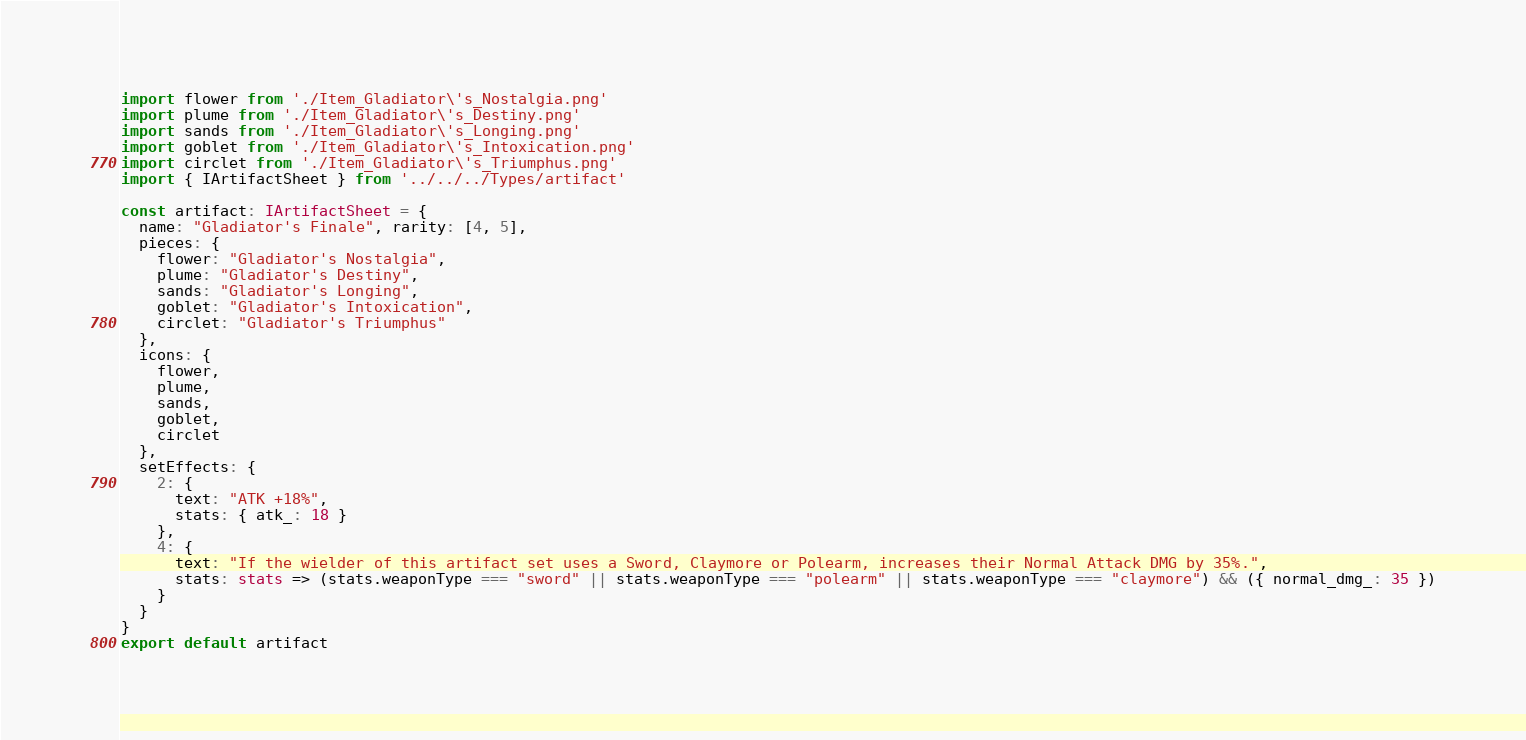<code> <loc_0><loc_0><loc_500><loc_500><_TypeScript_>import flower from './Item_Gladiator\'s_Nostalgia.png'
import plume from './Item_Gladiator\'s_Destiny.png'
import sands from './Item_Gladiator\'s_Longing.png'
import goblet from './Item_Gladiator\'s_Intoxication.png'
import circlet from './Item_Gladiator\'s_Triumphus.png'
import { IArtifactSheet } from '../../../Types/artifact'

const artifact: IArtifactSheet = {
  name: "Gladiator's Finale", rarity: [4, 5],
  pieces: {
    flower: "Gladiator's Nostalgia",
    plume: "Gladiator's Destiny",
    sands: "Gladiator's Longing",
    goblet: "Gladiator's Intoxication",
    circlet: "Gladiator's Triumphus"
  },
  icons: {
    flower,
    plume,
    sands,
    goblet,
    circlet
  },
  setEffects: {
    2: {
      text: "ATK +18%",
      stats: { atk_: 18 }
    },
    4: {
      text: "If the wielder of this artifact set uses a Sword, Claymore or Polearm, increases their Normal Attack DMG by 35%.",
      stats: stats => (stats.weaponType === "sword" || stats.weaponType === "polearm" || stats.weaponType === "claymore") && ({ normal_dmg_: 35 })
    }
  }
}
export default artifact</code> 